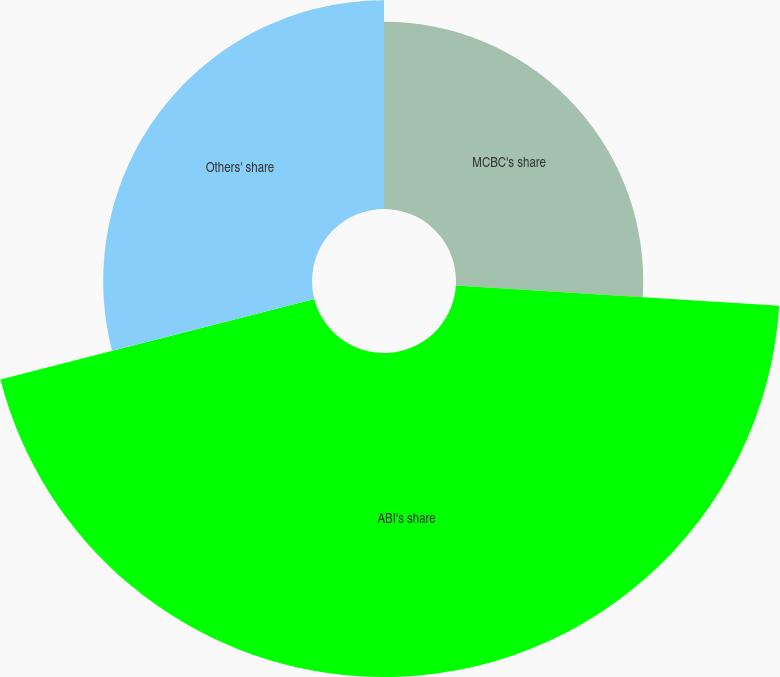<chart> <loc_0><loc_0><loc_500><loc_500><pie_chart><fcel>MCBC's share<fcel>ABI's share<fcel>Others' share<nl><fcel>26.0%<fcel>45.0%<fcel>29.0%<nl></chart> 